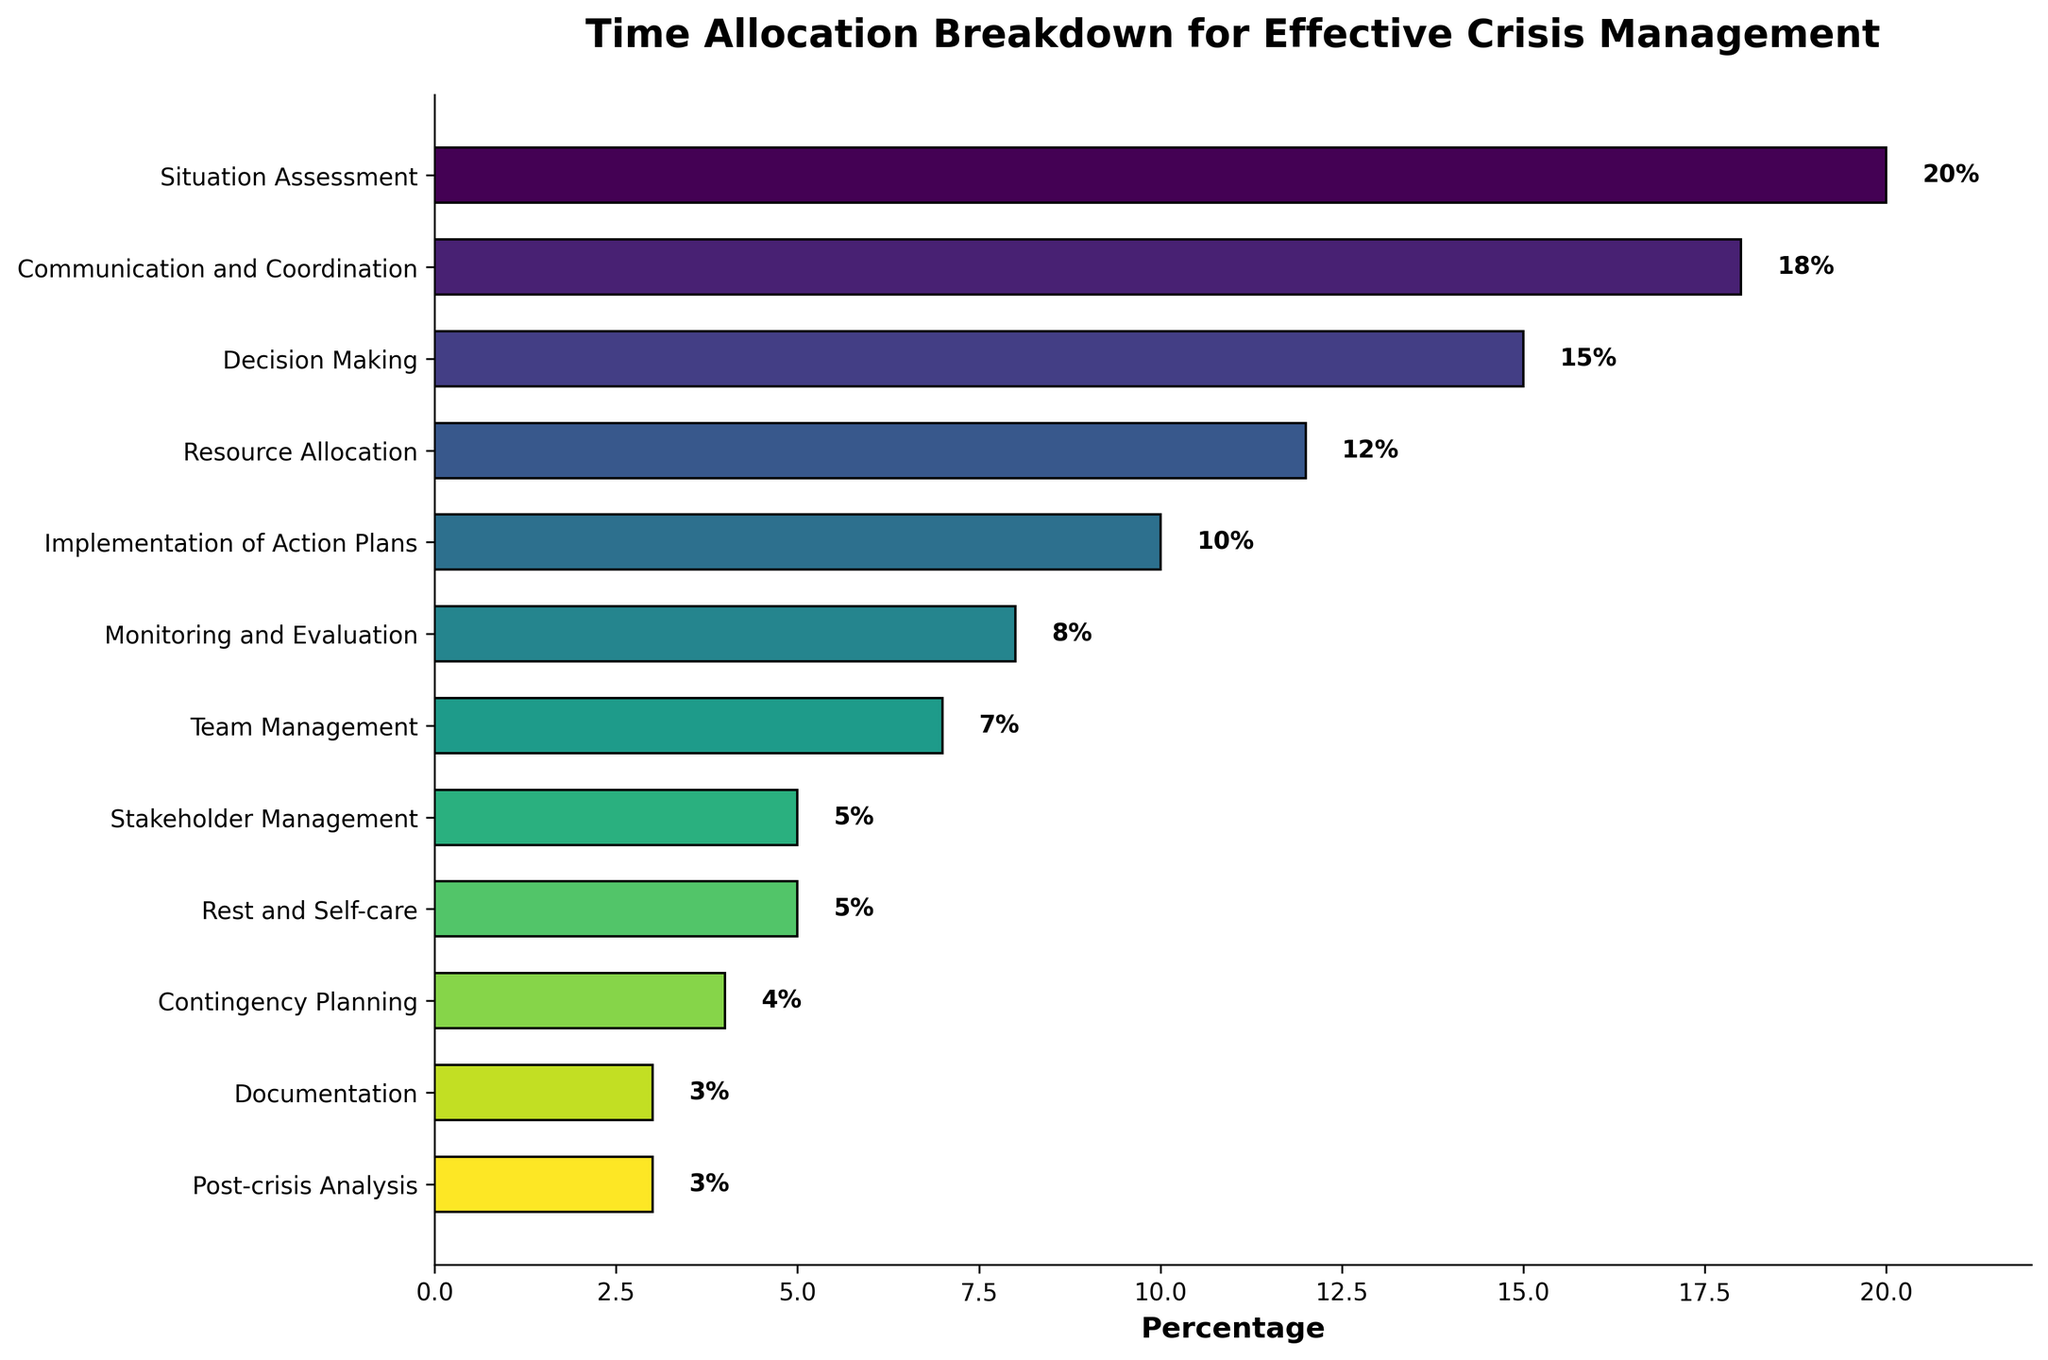Which category occupies the largest percentage of time allocation? To determine the category with the largest time allocation, look for the bar with the greatest length; the category at the far left of the graph is "Situation Assessment" with 20%.
Answer: Situation Assessment How much more time is allocated to Communication and Coordination than to Resource Allocation? Find the percentages for Communication and Coordination (18%) and Resource Allocation (12%). Subtract the lower percentage from the higher one: 18% - 12% = 6%.
Answer: 6% Which categories have the same percentage of time allocated to them? Identify categories with equal bar lengths. "Rest and Self-care" and "Stakeholder Management" both have a percentage of 5%. "Post-crisis Analysis" and "Documentation" both have a percentage of 3%.
Answer: Rest and Self-care and Stakeholder Management, Documentation and Post-crisis Analysis What is the total percentage of time allocated to Decision Making and Implementation of Action Plans combined? Find the percentages for Decision Making (15%) and Implementation of Action Plans (10%). Add them together: 15% + 10% = 25%.
Answer: 25% Is more time allocated to Monitoring and Evaluation or to Team Management? By how much? Compare the percentages for Monitoring and Evaluation (8%) and Team Management (7%). Monitoring and Evaluation has 1% more time allocated than Team Management.
Answer: Monitoring and Evaluation by 1% Which category has the shortest time allocation and what percentage is it? Look for the bar with the shortest length. "Post-crisis Analysis" and "Documentation" both have the shortest length at 3%.
Answer: Post-crisis Analysis and Documentation at 3% How does the time allocated to Communication and Coordination compare to the time allocated to Situation Assessment? Compare the percentages for Communication and Coordination (18%) and Situation Assessment (20%). Communication and Coordination is allocated 2% less time than Situation Assessment.
Answer: 2% less What is the combined percentage for all the categories that have less than 10% allocation? Identify and sum up the percentages of categories with less than 10%: Monitoring and Evaluation (8%), Team Management (7%), Stakeholder Management (5%), Rest and Self-care (5%), Contingency Planning (4%), Documentation (3%), Post-crisis Analysis (3%). Total is 8% + 7% + 5% + 5% + 4% + 3% + 3% = 35%.
Answer: 35% How much more time is allocated to Situation Assessment compared to Documentation? Compare the percentages for Situation Assessment (20%) and Documentation (3%). Subtract the smaller percentage from the larger: 20% - 3% = 17%.
Answer: 17% Which category is allocated more time: Resource Allocation or Team Management? Compare the bar lengths or percentages of Resource Allocation (12%) and Team Management (7%). Resource Allocation has more time allocated than Team Management.
Answer: Resource Allocation 